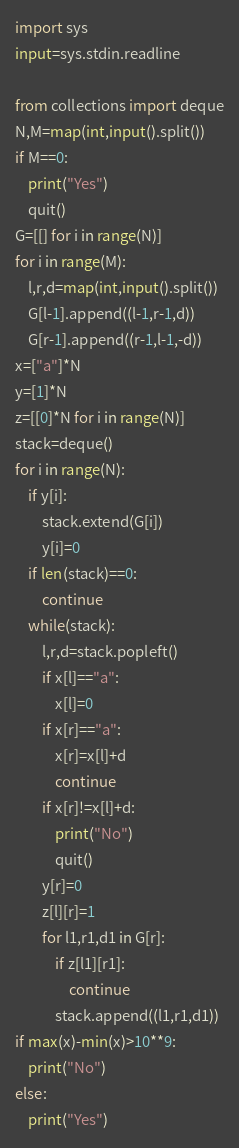Convert code to text. <code><loc_0><loc_0><loc_500><loc_500><_Python_>import sys
input=sys.stdin.readline

from collections import deque
N,M=map(int,input().split())
if M==0:
    print("Yes")
    quit()
G=[[] for i in range(N)]
for i in range(M):
    l,r,d=map(int,input().split())
    G[l-1].append((l-1,r-1,d))
    G[r-1].append((r-1,l-1,-d))
x=["a"]*N
y=[1]*N
z=[[0]*N for i in range(N)]
stack=deque()
for i in range(N):
    if y[i]:
        stack.extend(G[i])
        y[i]=0
    if len(stack)==0:
        continue
    while(stack):
        l,r,d=stack.popleft()
        if x[l]=="a":
            x[l]=0
        if x[r]=="a":
            x[r]=x[l]+d
            continue
        if x[r]!=x[l]+d:
            print("No")
            quit()
        y[r]=0
        z[l][r]=1
        for l1,r1,d1 in G[r]:
            if z[l1][r1]:
                continue
            stack.append((l1,r1,d1))
if max(x)-min(x)>10**9:
    print("No")
else:
    print("Yes")
</code> 